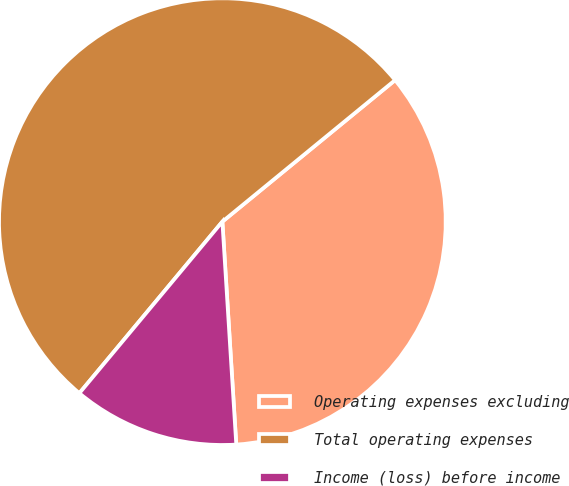Convert chart. <chart><loc_0><loc_0><loc_500><loc_500><pie_chart><fcel>Operating expenses excluding<fcel>Total operating expenses<fcel>Income (loss) before income<nl><fcel>34.93%<fcel>53.01%<fcel>12.05%<nl></chart> 